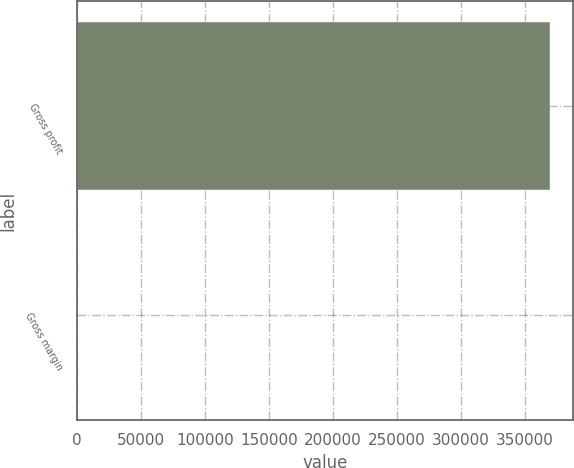Convert chart. <chart><loc_0><loc_0><loc_500><loc_500><bar_chart><fcel>Gross profit<fcel>Gross margin<nl><fcel>369675<fcel>37.1<nl></chart> 